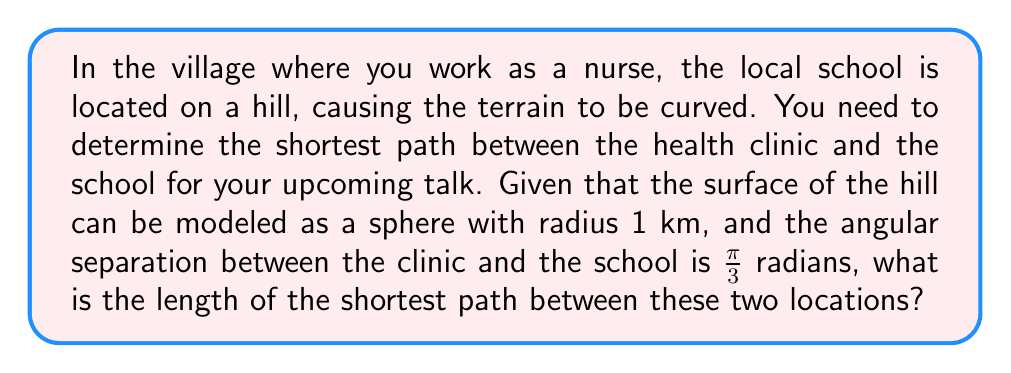What is the answer to this math problem? To solve this problem, we need to use concepts from spherical geometry, which is a type of non-Euclidean geometry.

Step 1: Recognize that the shortest path between two points on a sphere is along a great circle, which is the intersection of the sphere with a plane passing through its center.

Step 2: The length of this path is given by the arc length formula for a sphere:
$$s = r\theta$$
where $s$ is the arc length, $r$ is the radius of the sphere, and $\theta$ is the central angle in radians.

Step 3: We are given:
- Radius of the sphere (hill) $r = 1$ km
- Angular separation $\theta = \frac{\pi}{3}$ radians

Step 4: Substitute these values into the arc length formula:
$$s = 1 \cdot \frac{\pi}{3} = \frac{\pi}{3}$$

Step 5: The result is in kilometers since our radius was given in kilometers.

Therefore, the shortest path between the health clinic and the school is $\frac{\pi}{3}$ km long.
Answer: $\frac{\pi}{3}$ km 